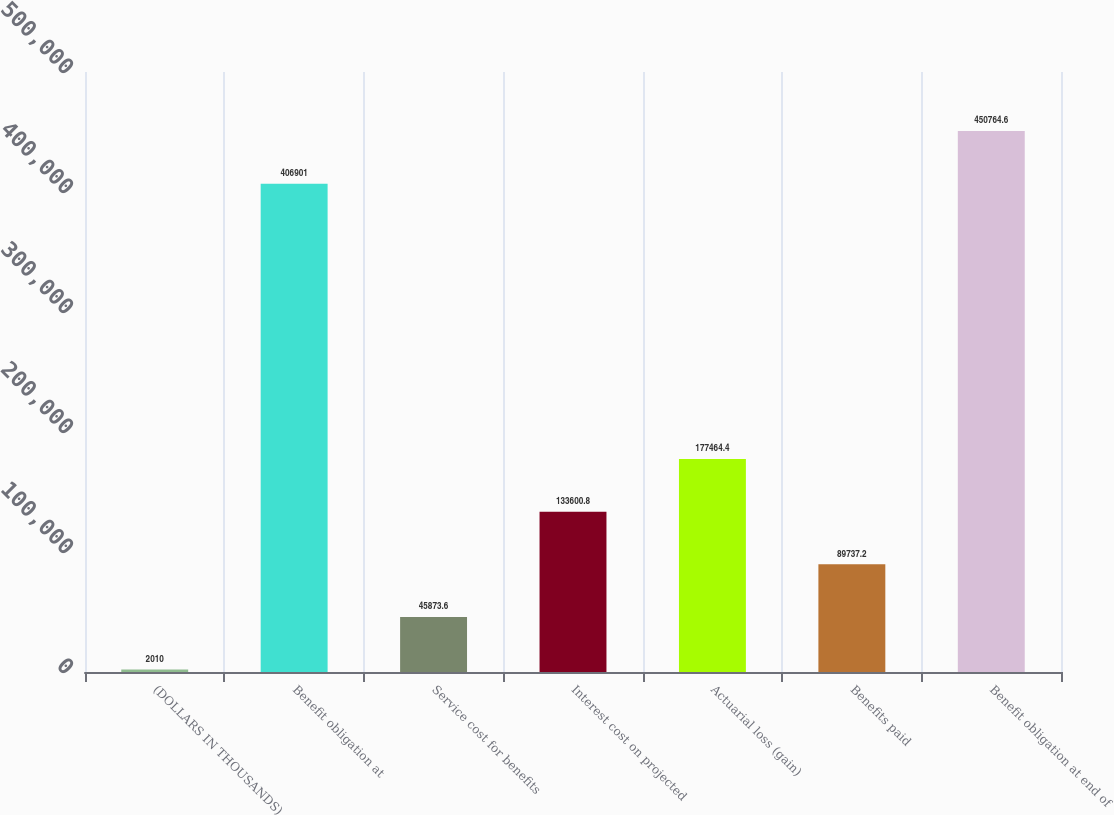<chart> <loc_0><loc_0><loc_500><loc_500><bar_chart><fcel>(DOLLARS IN THOUSANDS)<fcel>Benefit obligation at<fcel>Service cost for benefits<fcel>Interest cost on projected<fcel>Actuarial loss (gain)<fcel>Benefits paid<fcel>Benefit obligation at end of<nl><fcel>2010<fcel>406901<fcel>45873.6<fcel>133601<fcel>177464<fcel>89737.2<fcel>450765<nl></chart> 